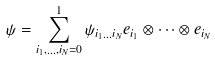<formula> <loc_0><loc_0><loc_500><loc_500>\psi = \sum _ { i _ { 1 } , \dots , i _ { N } = 0 } ^ { 1 } \psi _ { i _ { 1 } \dots i _ { N } } e _ { i _ { 1 } } \otimes \cdots \otimes e _ { i _ { N } }</formula> 